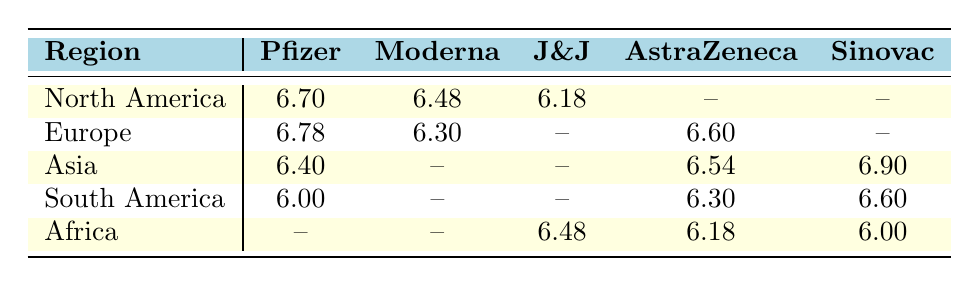What is the highest number of vaccine supplies for Pfizer and in which region is it located? The highest value for Pfizer is 6.78, located in Europe.
Answer: 6.78 (Europe) Which region has the highest supply of Sinovac? The highest supply of Sinovac is 8.00, located in Asia.
Answer: 8.00 (Asia) Does North America have any supply of AstraZeneca vaccines? North America has no supply of AstraZeneca vaccines, as indicated by the "--" in the table.
Answer: No What is the average supply of Moderna vaccines across all regions? The available values for Moderna are 6.48 (North America), 6.30 (Europe), and absence in Asia, South America, and Africa, so, average = (6.48 + 6.30) / 2 = 6.39.
Answer: 6.39 How many regions have Johnson & Johnson vaccine supplies available? There are two regions with Johnson & Johnson vaccine supplies, which are North America (6.18) and Africa (6.48).
Answer: 2 Which vaccine has the lowest supply in South America and what is its value? The lowest supply in South America is for Pfizer at 6.00.
Answer: 6.00 (Pfizer) Is the supply of AstraZeneca vaccines higher in Europe than in Africa? Yes, Europe has 6.60 supplies of AstraZeneca compared to 6.18 in Africa.
Answer: Yes If you sum the available supplies of Pfizer and Moderna for North America, what is the total? The supplies are 6.70 (Pfizer) + 6.48 (Moderna) = 13.18.
Answer: 13.18 Which two vaccines are available in both Asia and South America? The two vaccines are AstraZeneca and Sinovac, which are in Asia (6.54, 6.90) and South America (6.30, 6.60) respectively.
Answer: AstraZeneca, Sinovac 